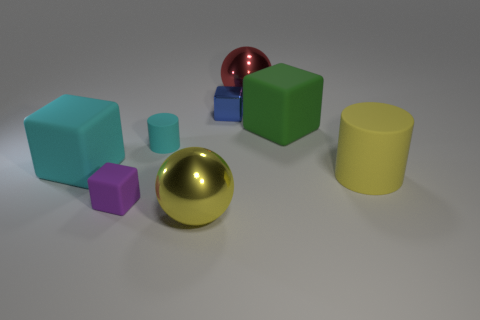Does the blue thing have the same size as the metallic object on the left side of the small metal thing?
Offer a very short reply. No. What number of objects are either blue shiny cubes or big yellow matte spheres?
Give a very brief answer. 1. How many other things are the same size as the red sphere?
Offer a terse response. 4. Do the small rubber block and the matte block that is to the left of the small purple thing have the same color?
Your answer should be very brief. No. How many cylinders are gray rubber things or blue things?
Offer a terse response. 0. Is there anything else that has the same color as the metallic cube?
Keep it short and to the point. No. There is a yellow object behind the cube in front of the large rubber cylinder; what is it made of?
Provide a short and direct response. Rubber. Does the large yellow cylinder have the same material as the yellow thing that is left of the big red metallic ball?
Your answer should be very brief. No. How many things are either small cubes that are behind the large yellow cylinder or tiny gray metal cylinders?
Provide a succinct answer. 1. Is there a big rubber thing that has the same color as the metallic cube?
Your answer should be compact. No. 